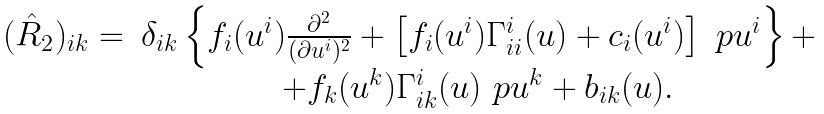<formula> <loc_0><loc_0><loc_500><loc_500>\begin{array} { c c } ( \hat { R } _ { 2 } ) _ { i k } = & \delta _ { i k } \left \{ f _ { i } ( u ^ { i } ) \frac { \partial ^ { 2 } } { ( \partial u ^ { i } ) ^ { 2 } } + \left [ f _ { i } ( u ^ { i } ) \Gamma ^ { i } _ { i i } ( u ) + c _ { i } ( u ^ { i } ) \right ] \ p { u ^ { i } } \right \} + \\ & + f _ { k } ( u ^ { k } ) \Gamma ^ { i } _ { i k } ( u ) \ p { u ^ { k } } + b _ { i k } ( u ) . \end{array}</formula> 